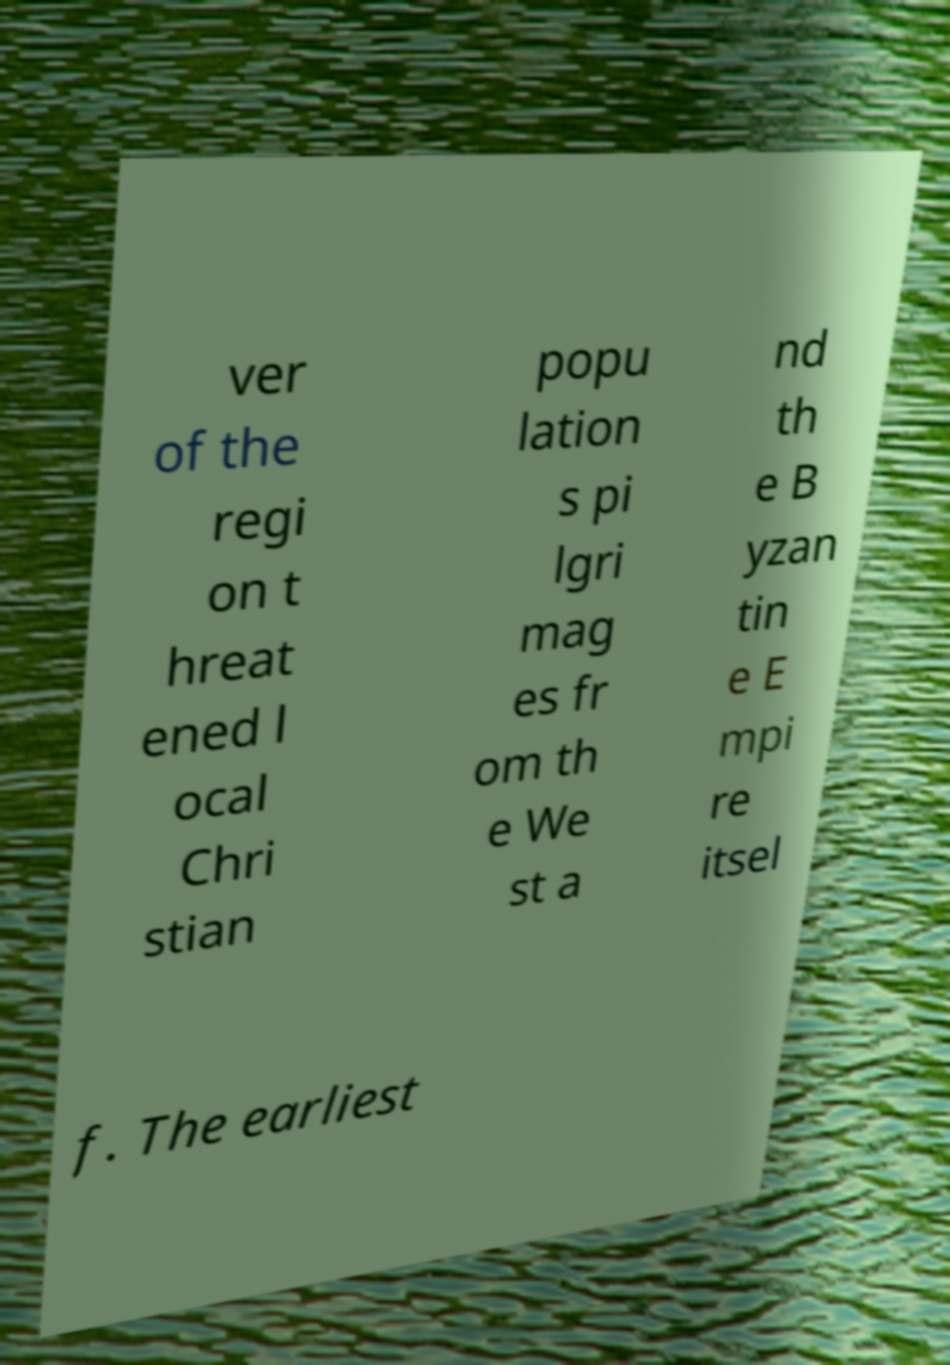Can you read and provide the text displayed in the image?This photo seems to have some interesting text. Can you extract and type it out for me? ver of the regi on t hreat ened l ocal Chri stian popu lation s pi lgri mag es fr om th e We st a nd th e B yzan tin e E mpi re itsel f. The earliest 